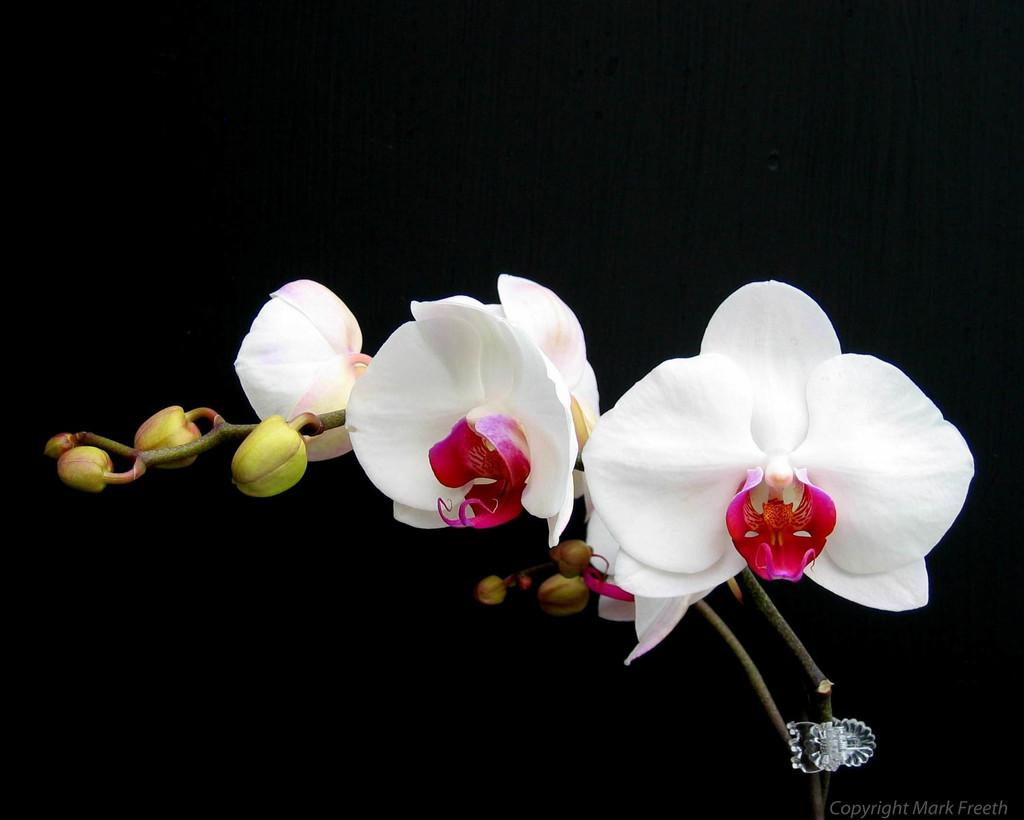What type of plants can be seen in the image? There are flowers in the image. Can you describe the stage of growth for some of the plants? There are buds in the image, which are at an early stage of growth. What is the color of the background in the image? The background of the image is dark. What position does the lake hold in the image? There is no lake present in the image. How often do the flowers need to be washed in the image? The flowers do not need to be washed in the image, as they are not real and are part of a photograph or illustration. 